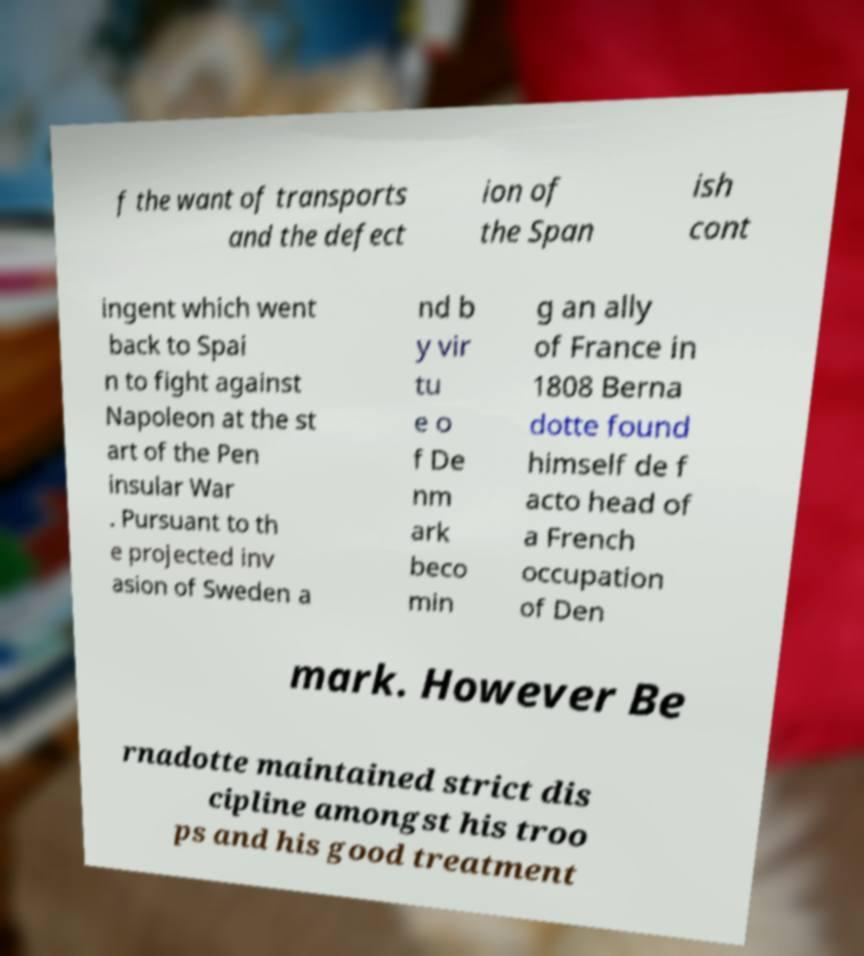Please read and relay the text visible in this image. What does it say? f the want of transports and the defect ion of the Span ish cont ingent which went back to Spai n to fight against Napoleon at the st art of the Pen insular War . Pursuant to th e projected inv asion of Sweden a nd b y vir tu e o f De nm ark beco min g an ally of France in 1808 Berna dotte found himself de f acto head of a French occupation of Den mark. However Be rnadotte maintained strict dis cipline amongst his troo ps and his good treatment 